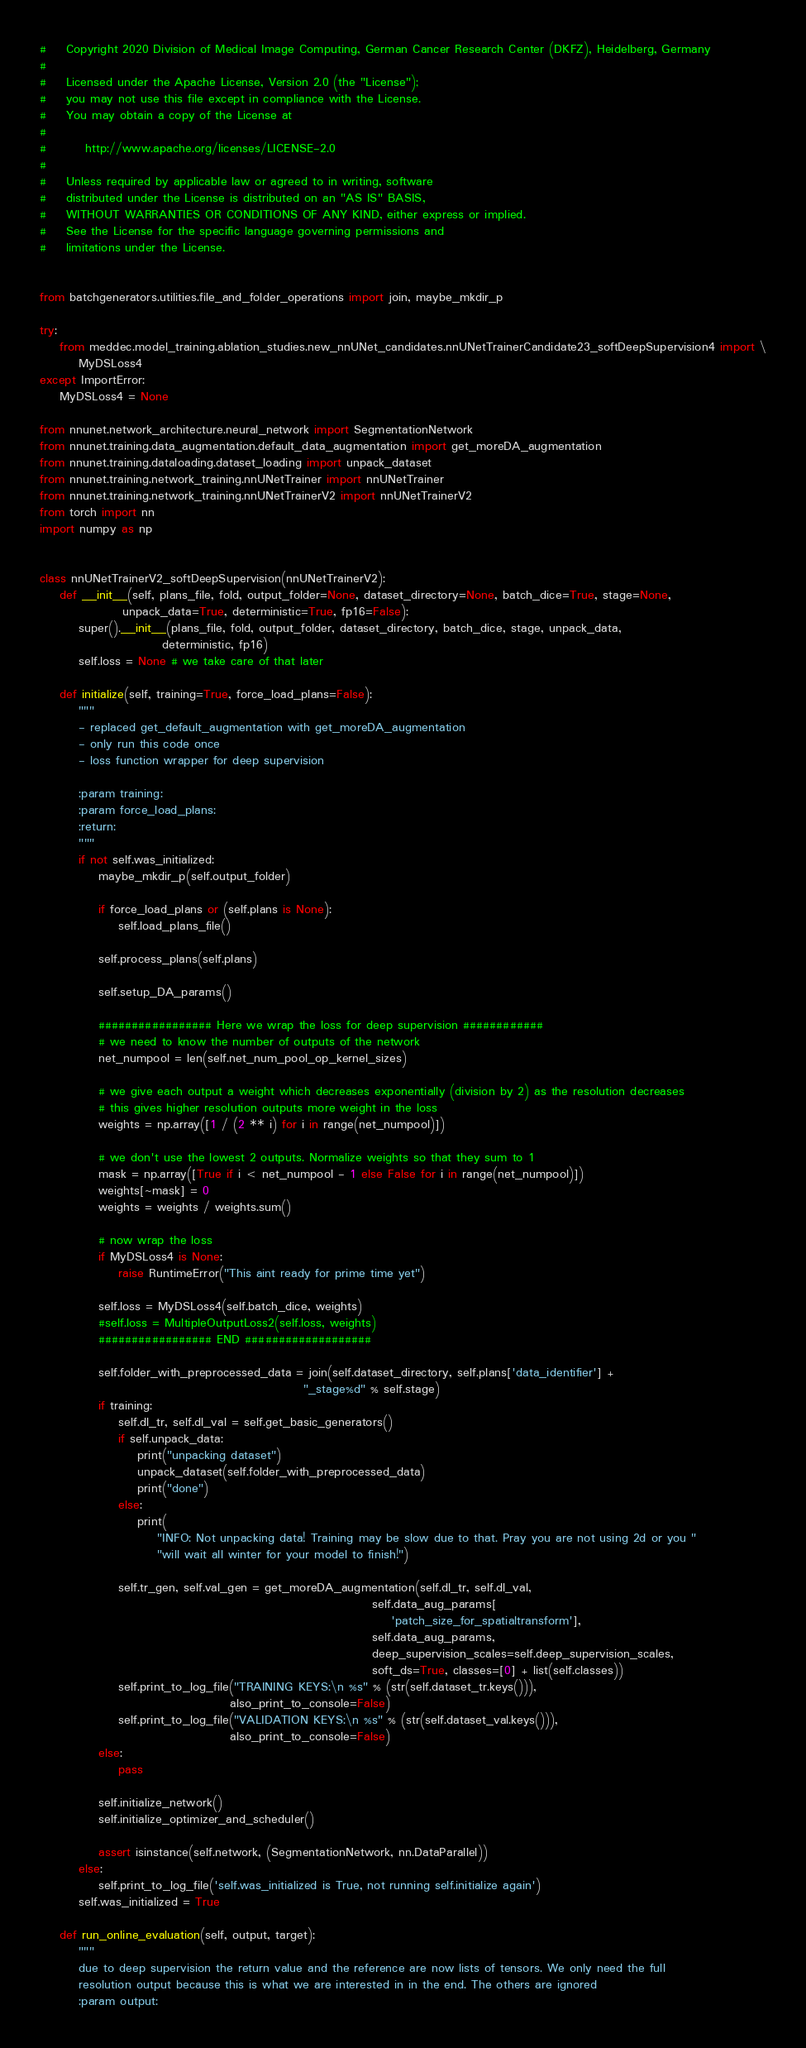<code> <loc_0><loc_0><loc_500><loc_500><_Python_>#    Copyright 2020 Division of Medical Image Computing, German Cancer Research Center (DKFZ), Heidelberg, Germany
#
#    Licensed under the Apache License, Version 2.0 (the "License");
#    you may not use this file except in compliance with the License.
#    You may obtain a copy of the License at
#
#        http://www.apache.org/licenses/LICENSE-2.0
#
#    Unless required by applicable law or agreed to in writing, software
#    distributed under the License is distributed on an "AS IS" BASIS,
#    WITHOUT WARRANTIES OR CONDITIONS OF ANY KIND, either express or implied.
#    See the License for the specific language governing permissions and
#    limitations under the License.


from batchgenerators.utilities.file_and_folder_operations import join, maybe_mkdir_p

try:
    from meddec.model_training.ablation_studies.new_nnUNet_candidates.nnUNetTrainerCandidate23_softDeepSupervision4 import \
        MyDSLoss4
except ImportError:
    MyDSLoss4 = None

from nnunet.network_architecture.neural_network import SegmentationNetwork
from nnunet.training.data_augmentation.default_data_augmentation import get_moreDA_augmentation
from nnunet.training.dataloading.dataset_loading import unpack_dataset
from nnunet.training.network_training.nnUNetTrainer import nnUNetTrainer
from nnunet.training.network_training.nnUNetTrainerV2 import nnUNetTrainerV2
from torch import nn
import numpy as np


class nnUNetTrainerV2_softDeepSupervision(nnUNetTrainerV2):
    def __init__(self, plans_file, fold, output_folder=None, dataset_directory=None, batch_dice=True, stage=None,
                 unpack_data=True, deterministic=True, fp16=False):
        super().__init__(plans_file, fold, output_folder, dataset_directory, batch_dice, stage, unpack_data,
                         deterministic, fp16)
        self.loss = None # we take care of that later

    def initialize(self, training=True, force_load_plans=False):
        """
        - replaced get_default_augmentation with get_moreDA_augmentation
        - only run this code once
        - loss function wrapper for deep supervision

        :param training:
        :param force_load_plans:
        :return:
        """
        if not self.was_initialized:
            maybe_mkdir_p(self.output_folder)

            if force_load_plans or (self.plans is None):
                self.load_plans_file()

            self.process_plans(self.plans)

            self.setup_DA_params()

            ################# Here we wrap the loss for deep supervision ############
            # we need to know the number of outputs of the network
            net_numpool = len(self.net_num_pool_op_kernel_sizes)

            # we give each output a weight which decreases exponentially (division by 2) as the resolution decreases
            # this gives higher resolution outputs more weight in the loss
            weights = np.array([1 / (2 ** i) for i in range(net_numpool)])

            # we don't use the lowest 2 outputs. Normalize weights so that they sum to 1
            mask = np.array([True if i < net_numpool - 1 else False for i in range(net_numpool)])
            weights[~mask] = 0
            weights = weights / weights.sum()

            # now wrap the loss
            if MyDSLoss4 is None:
                raise RuntimeError("This aint ready for prime time yet")

            self.loss = MyDSLoss4(self.batch_dice, weights)
            #self.loss = MultipleOutputLoss2(self.loss, weights)
            ################# END ###################

            self.folder_with_preprocessed_data = join(self.dataset_directory, self.plans['data_identifier'] +
                                                      "_stage%d" % self.stage)
            if training:
                self.dl_tr, self.dl_val = self.get_basic_generators()
                if self.unpack_data:
                    print("unpacking dataset")
                    unpack_dataset(self.folder_with_preprocessed_data)
                    print("done")
                else:
                    print(
                        "INFO: Not unpacking data! Training may be slow due to that. Pray you are not using 2d or you "
                        "will wait all winter for your model to finish!")

                self.tr_gen, self.val_gen = get_moreDA_augmentation(self.dl_tr, self.dl_val,
                                                                    self.data_aug_params[
                                                                        'patch_size_for_spatialtransform'],
                                                                    self.data_aug_params,
                                                                    deep_supervision_scales=self.deep_supervision_scales,
                                                                    soft_ds=True, classes=[0] + list(self.classes))
                self.print_to_log_file("TRAINING KEYS:\n %s" % (str(self.dataset_tr.keys())),
                                       also_print_to_console=False)
                self.print_to_log_file("VALIDATION KEYS:\n %s" % (str(self.dataset_val.keys())),
                                       also_print_to_console=False)
            else:
                pass

            self.initialize_network()
            self.initialize_optimizer_and_scheduler()

            assert isinstance(self.network, (SegmentationNetwork, nn.DataParallel))
        else:
            self.print_to_log_file('self.was_initialized is True, not running self.initialize again')
        self.was_initialized = True

    def run_online_evaluation(self, output, target):
        """
        due to deep supervision the return value and the reference are now lists of tensors. We only need the full
        resolution output because this is what we are interested in in the end. The others are ignored
        :param output:</code> 